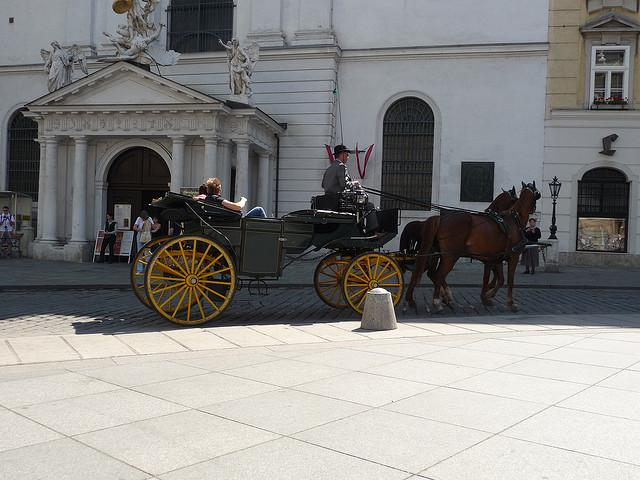What is being held by the person sitting highest? Please explain your reasoning. reins. The driver with the reins is sitting up the highest. 